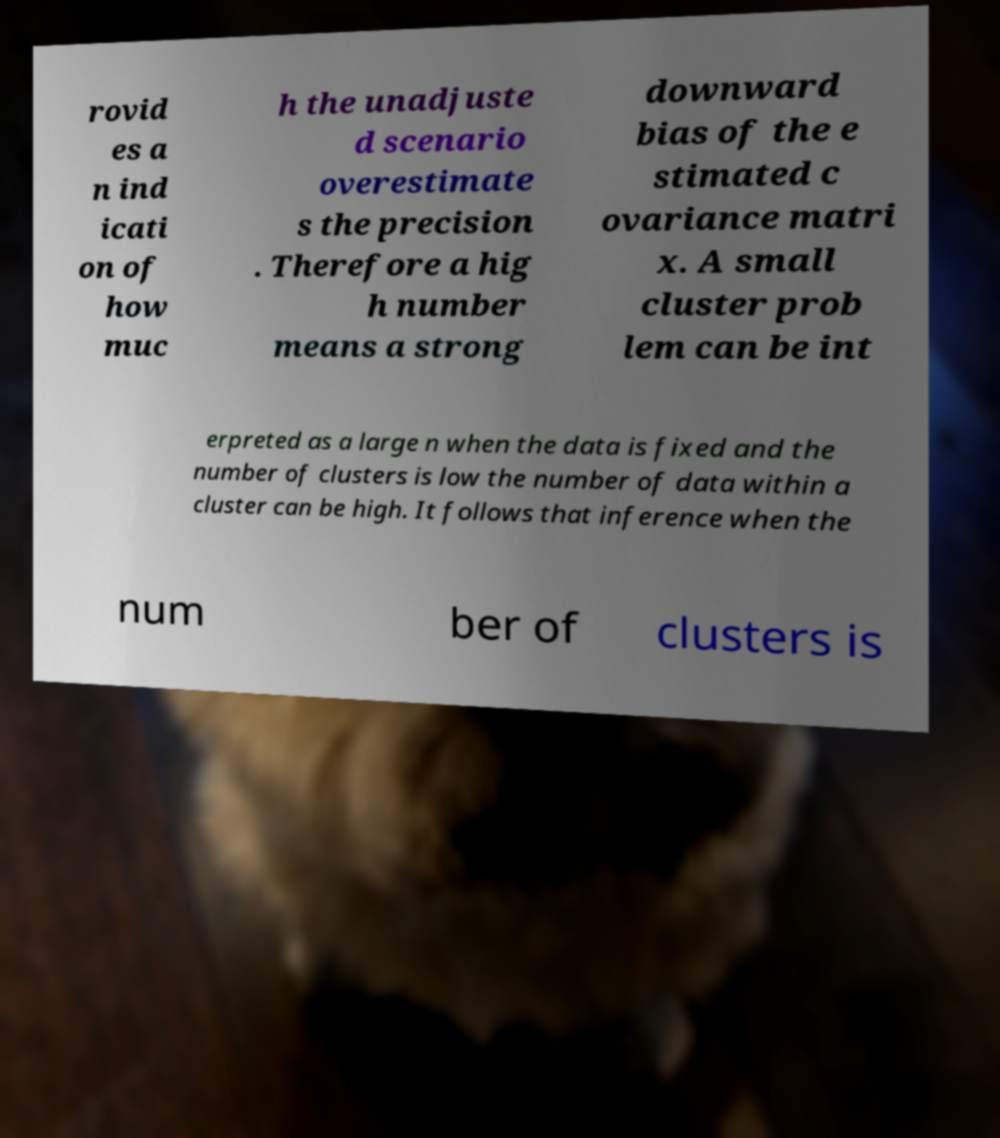For documentation purposes, I need the text within this image transcribed. Could you provide that? rovid es a n ind icati on of how muc h the unadjuste d scenario overestimate s the precision . Therefore a hig h number means a strong downward bias of the e stimated c ovariance matri x. A small cluster prob lem can be int erpreted as a large n when the data is fixed and the number of clusters is low the number of data within a cluster can be high. It follows that inference when the num ber of clusters is 